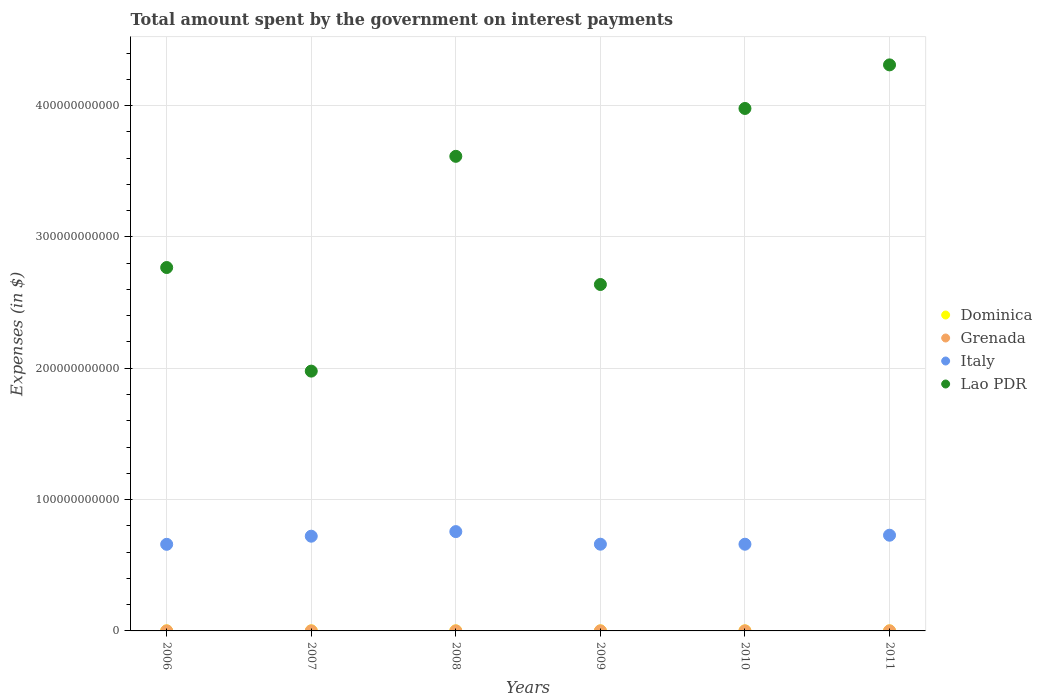Is the number of dotlines equal to the number of legend labels?
Give a very brief answer. Yes. What is the amount spent on interest payments by the government in Lao PDR in 2007?
Give a very brief answer. 1.98e+11. Across all years, what is the maximum amount spent on interest payments by the government in Lao PDR?
Offer a terse response. 4.31e+11. Across all years, what is the minimum amount spent on interest payments by the government in Dominica?
Your answer should be very brief. 1.41e+07. What is the total amount spent on interest payments by the government in Italy in the graph?
Give a very brief answer. 4.19e+11. What is the difference between the amount spent on interest payments by the government in Lao PDR in 2006 and that in 2009?
Your answer should be compact. 1.29e+1. What is the difference between the amount spent on interest payments by the government in Lao PDR in 2007 and the amount spent on interest payments by the government in Italy in 2008?
Ensure brevity in your answer.  1.22e+11. What is the average amount spent on interest payments by the government in Italy per year?
Provide a short and direct response. 6.98e+1. In the year 2010, what is the difference between the amount spent on interest payments by the government in Grenada and amount spent on interest payments by the government in Lao PDR?
Offer a terse response. -3.98e+11. In how many years, is the amount spent on interest payments by the government in Lao PDR greater than 220000000000 $?
Provide a succinct answer. 5. What is the ratio of the amount spent on interest payments by the government in Dominica in 2006 to that in 2008?
Your answer should be compact. 1.41. Is the amount spent on interest payments by the government in Grenada in 2006 less than that in 2010?
Provide a short and direct response. Yes. Is the difference between the amount spent on interest payments by the government in Grenada in 2008 and 2009 greater than the difference between the amount spent on interest payments by the government in Lao PDR in 2008 and 2009?
Your answer should be very brief. No. What is the difference between the highest and the second highest amount spent on interest payments by the government in Grenada?
Offer a very short reply. 6.30e+06. What is the difference between the highest and the lowest amount spent on interest payments by the government in Dominica?
Keep it short and to the point. 2.05e+07. Is it the case that in every year, the sum of the amount spent on interest payments by the government in Grenada and amount spent on interest payments by the government in Dominica  is greater than the sum of amount spent on interest payments by the government in Italy and amount spent on interest payments by the government in Lao PDR?
Provide a short and direct response. No. Does the amount spent on interest payments by the government in Italy monotonically increase over the years?
Make the answer very short. No. What is the difference between two consecutive major ticks on the Y-axis?
Offer a very short reply. 1.00e+11. Are the values on the major ticks of Y-axis written in scientific E-notation?
Ensure brevity in your answer.  No. Does the graph contain any zero values?
Offer a very short reply. No. Does the graph contain grids?
Give a very brief answer. Yes. Where does the legend appear in the graph?
Make the answer very short. Center right. What is the title of the graph?
Provide a succinct answer. Total amount spent by the government on interest payments. What is the label or title of the X-axis?
Ensure brevity in your answer.  Years. What is the label or title of the Y-axis?
Your answer should be compact. Expenses (in $). What is the Expenses (in $) of Dominica in 2006?
Make the answer very short. 3.46e+07. What is the Expenses (in $) of Grenada in 2006?
Your answer should be very brief. 2.90e+07. What is the Expenses (in $) of Italy in 2006?
Provide a succinct answer. 6.59e+1. What is the Expenses (in $) of Lao PDR in 2006?
Your response must be concise. 2.77e+11. What is the Expenses (in $) of Dominica in 2007?
Your response must be concise. 2.82e+07. What is the Expenses (in $) of Grenada in 2007?
Your answer should be very brief. 3.30e+07. What is the Expenses (in $) in Italy in 2007?
Offer a very short reply. 7.21e+1. What is the Expenses (in $) in Lao PDR in 2007?
Give a very brief answer. 1.98e+11. What is the Expenses (in $) of Dominica in 2008?
Your answer should be very brief. 2.45e+07. What is the Expenses (in $) in Grenada in 2008?
Provide a succinct answer. 3.49e+07. What is the Expenses (in $) of Italy in 2008?
Give a very brief answer. 7.56e+1. What is the Expenses (in $) in Lao PDR in 2008?
Your response must be concise. 3.61e+11. What is the Expenses (in $) of Dominica in 2009?
Your answer should be compact. 1.41e+07. What is the Expenses (in $) in Grenada in 2009?
Provide a succinct answer. 4.53e+07. What is the Expenses (in $) in Italy in 2009?
Ensure brevity in your answer.  6.60e+1. What is the Expenses (in $) in Lao PDR in 2009?
Provide a succinct answer. 2.64e+11. What is the Expenses (in $) in Dominica in 2010?
Ensure brevity in your answer.  2.10e+07. What is the Expenses (in $) of Grenada in 2010?
Give a very brief answer. 4.30e+07. What is the Expenses (in $) of Italy in 2010?
Your answer should be compact. 6.60e+1. What is the Expenses (in $) in Lao PDR in 2010?
Your answer should be compact. 3.98e+11. What is the Expenses (in $) of Dominica in 2011?
Ensure brevity in your answer.  2.46e+07. What is the Expenses (in $) of Grenada in 2011?
Provide a short and direct response. 5.16e+07. What is the Expenses (in $) in Italy in 2011?
Give a very brief answer. 7.29e+1. What is the Expenses (in $) in Lao PDR in 2011?
Make the answer very short. 4.31e+11. Across all years, what is the maximum Expenses (in $) in Dominica?
Offer a terse response. 3.46e+07. Across all years, what is the maximum Expenses (in $) of Grenada?
Your response must be concise. 5.16e+07. Across all years, what is the maximum Expenses (in $) of Italy?
Provide a succinct answer. 7.56e+1. Across all years, what is the maximum Expenses (in $) in Lao PDR?
Your answer should be very brief. 4.31e+11. Across all years, what is the minimum Expenses (in $) in Dominica?
Keep it short and to the point. 1.41e+07. Across all years, what is the minimum Expenses (in $) of Grenada?
Ensure brevity in your answer.  2.90e+07. Across all years, what is the minimum Expenses (in $) of Italy?
Your answer should be very brief. 6.59e+1. Across all years, what is the minimum Expenses (in $) of Lao PDR?
Your response must be concise. 1.98e+11. What is the total Expenses (in $) of Dominica in the graph?
Keep it short and to the point. 1.47e+08. What is the total Expenses (in $) in Grenada in the graph?
Your answer should be very brief. 2.37e+08. What is the total Expenses (in $) of Italy in the graph?
Provide a succinct answer. 4.19e+11. What is the total Expenses (in $) of Lao PDR in the graph?
Make the answer very short. 1.93e+12. What is the difference between the Expenses (in $) of Dominica in 2006 and that in 2007?
Give a very brief answer. 6.40e+06. What is the difference between the Expenses (in $) of Italy in 2006 and that in 2007?
Keep it short and to the point. -6.18e+09. What is the difference between the Expenses (in $) in Lao PDR in 2006 and that in 2007?
Your answer should be very brief. 7.89e+1. What is the difference between the Expenses (in $) in Dominica in 2006 and that in 2008?
Provide a succinct answer. 1.01e+07. What is the difference between the Expenses (in $) of Grenada in 2006 and that in 2008?
Keep it short and to the point. -5.90e+06. What is the difference between the Expenses (in $) in Italy in 2006 and that in 2008?
Your answer should be compact. -9.68e+09. What is the difference between the Expenses (in $) of Lao PDR in 2006 and that in 2008?
Give a very brief answer. -8.47e+1. What is the difference between the Expenses (in $) in Dominica in 2006 and that in 2009?
Offer a terse response. 2.05e+07. What is the difference between the Expenses (in $) of Grenada in 2006 and that in 2009?
Your answer should be compact. -1.63e+07. What is the difference between the Expenses (in $) in Italy in 2006 and that in 2009?
Your answer should be very brief. -8.80e+07. What is the difference between the Expenses (in $) in Lao PDR in 2006 and that in 2009?
Offer a terse response. 1.29e+1. What is the difference between the Expenses (in $) of Dominica in 2006 and that in 2010?
Provide a succinct answer. 1.36e+07. What is the difference between the Expenses (in $) of Grenada in 2006 and that in 2010?
Offer a very short reply. -1.40e+07. What is the difference between the Expenses (in $) in Italy in 2006 and that in 2010?
Give a very brief answer. -7.20e+07. What is the difference between the Expenses (in $) of Lao PDR in 2006 and that in 2010?
Offer a terse response. -1.21e+11. What is the difference between the Expenses (in $) of Dominica in 2006 and that in 2011?
Offer a terse response. 1.00e+07. What is the difference between the Expenses (in $) in Grenada in 2006 and that in 2011?
Your answer should be compact. -2.26e+07. What is the difference between the Expenses (in $) in Italy in 2006 and that in 2011?
Offer a very short reply. -6.93e+09. What is the difference between the Expenses (in $) of Lao PDR in 2006 and that in 2011?
Provide a short and direct response. -1.54e+11. What is the difference between the Expenses (in $) in Dominica in 2007 and that in 2008?
Your answer should be compact. 3.70e+06. What is the difference between the Expenses (in $) in Grenada in 2007 and that in 2008?
Your response must be concise. -1.90e+06. What is the difference between the Expenses (in $) of Italy in 2007 and that in 2008?
Your answer should be very brief. -3.50e+09. What is the difference between the Expenses (in $) in Lao PDR in 2007 and that in 2008?
Your response must be concise. -1.64e+11. What is the difference between the Expenses (in $) of Dominica in 2007 and that in 2009?
Your answer should be very brief. 1.41e+07. What is the difference between the Expenses (in $) of Grenada in 2007 and that in 2009?
Your answer should be compact. -1.23e+07. What is the difference between the Expenses (in $) of Italy in 2007 and that in 2009?
Ensure brevity in your answer.  6.09e+09. What is the difference between the Expenses (in $) in Lao PDR in 2007 and that in 2009?
Keep it short and to the point. -6.60e+1. What is the difference between the Expenses (in $) in Dominica in 2007 and that in 2010?
Offer a very short reply. 7.20e+06. What is the difference between the Expenses (in $) in Grenada in 2007 and that in 2010?
Provide a short and direct response. -1.00e+07. What is the difference between the Expenses (in $) of Italy in 2007 and that in 2010?
Provide a succinct answer. 6.11e+09. What is the difference between the Expenses (in $) of Lao PDR in 2007 and that in 2010?
Your answer should be very brief. -2.00e+11. What is the difference between the Expenses (in $) of Dominica in 2007 and that in 2011?
Provide a short and direct response. 3.60e+06. What is the difference between the Expenses (in $) in Grenada in 2007 and that in 2011?
Ensure brevity in your answer.  -1.86e+07. What is the difference between the Expenses (in $) of Italy in 2007 and that in 2011?
Make the answer very short. -7.51e+08. What is the difference between the Expenses (in $) of Lao PDR in 2007 and that in 2011?
Give a very brief answer. -2.33e+11. What is the difference between the Expenses (in $) in Dominica in 2008 and that in 2009?
Offer a terse response. 1.04e+07. What is the difference between the Expenses (in $) of Grenada in 2008 and that in 2009?
Your answer should be compact. -1.04e+07. What is the difference between the Expenses (in $) in Italy in 2008 and that in 2009?
Your response must be concise. 9.59e+09. What is the difference between the Expenses (in $) of Lao PDR in 2008 and that in 2009?
Ensure brevity in your answer.  9.76e+1. What is the difference between the Expenses (in $) of Dominica in 2008 and that in 2010?
Provide a short and direct response. 3.50e+06. What is the difference between the Expenses (in $) in Grenada in 2008 and that in 2010?
Your answer should be compact. -8.10e+06. What is the difference between the Expenses (in $) in Italy in 2008 and that in 2010?
Ensure brevity in your answer.  9.61e+09. What is the difference between the Expenses (in $) of Lao PDR in 2008 and that in 2010?
Your answer should be compact. -3.64e+1. What is the difference between the Expenses (in $) of Dominica in 2008 and that in 2011?
Offer a very short reply. -1.00e+05. What is the difference between the Expenses (in $) in Grenada in 2008 and that in 2011?
Give a very brief answer. -1.67e+07. What is the difference between the Expenses (in $) of Italy in 2008 and that in 2011?
Give a very brief answer. 2.75e+09. What is the difference between the Expenses (in $) of Lao PDR in 2008 and that in 2011?
Provide a short and direct response. -6.96e+1. What is the difference between the Expenses (in $) in Dominica in 2009 and that in 2010?
Offer a terse response. -6.90e+06. What is the difference between the Expenses (in $) in Grenada in 2009 and that in 2010?
Your response must be concise. 2.30e+06. What is the difference between the Expenses (in $) of Italy in 2009 and that in 2010?
Keep it short and to the point. 1.60e+07. What is the difference between the Expenses (in $) of Lao PDR in 2009 and that in 2010?
Keep it short and to the point. -1.34e+11. What is the difference between the Expenses (in $) of Dominica in 2009 and that in 2011?
Offer a terse response. -1.05e+07. What is the difference between the Expenses (in $) of Grenada in 2009 and that in 2011?
Provide a short and direct response. -6.30e+06. What is the difference between the Expenses (in $) of Italy in 2009 and that in 2011?
Provide a succinct answer. -6.84e+09. What is the difference between the Expenses (in $) of Lao PDR in 2009 and that in 2011?
Your answer should be compact. -1.67e+11. What is the difference between the Expenses (in $) of Dominica in 2010 and that in 2011?
Ensure brevity in your answer.  -3.60e+06. What is the difference between the Expenses (in $) in Grenada in 2010 and that in 2011?
Your response must be concise. -8.60e+06. What is the difference between the Expenses (in $) in Italy in 2010 and that in 2011?
Give a very brief answer. -6.86e+09. What is the difference between the Expenses (in $) in Lao PDR in 2010 and that in 2011?
Make the answer very short. -3.32e+1. What is the difference between the Expenses (in $) of Dominica in 2006 and the Expenses (in $) of Grenada in 2007?
Your response must be concise. 1.60e+06. What is the difference between the Expenses (in $) in Dominica in 2006 and the Expenses (in $) in Italy in 2007?
Keep it short and to the point. -7.21e+1. What is the difference between the Expenses (in $) in Dominica in 2006 and the Expenses (in $) in Lao PDR in 2007?
Ensure brevity in your answer.  -1.98e+11. What is the difference between the Expenses (in $) in Grenada in 2006 and the Expenses (in $) in Italy in 2007?
Provide a succinct answer. -7.21e+1. What is the difference between the Expenses (in $) in Grenada in 2006 and the Expenses (in $) in Lao PDR in 2007?
Ensure brevity in your answer.  -1.98e+11. What is the difference between the Expenses (in $) in Italy in 2006 and the Expenses (in $) in Lao PDR in 2007?
Give a very brief answer. -1.32e+11. What is the difference between the Expenses (in $) in Dominica in 2006 and the Expenses (in $) in Grenada in 2008?
Make the answer very short. -3.00e+05. What is the difference between the Expenses (in $) in Dominica in 2006 and the Expenses (in $) in Italy in 2008?
Ensure brevity in your answer.  -7.56e+1. What is the difference between the Expenses (in $) in Dominica in 2006 and the Expenses (in $) in Lao PDR in 2008?
Keep it short and to the point. -3.61e+11. What is the difference between the Expenses (in $) in Grenada in 2006 and the Expenses (in $) in Italy in 2008?
Keep it short and to the point. -7.56e+1. What is the difference between the Expenses (in $) in Grenada in 2006 and the Expenses (in $) in Lao PDR in 2008?
Your response must be concise. -3.61e+11. What is the difference between the Expenses (in $) of Italy in 2006 and the Expenses (in $) of Lao PDR in 2008?
Keep it short and to the point. -2.95e+11. What is the difference between the Expenses (in $) in Dominica in 2006 and the Expenses (in $) in Grenada in 2009?
Ensure brevity in your answer.  -1.07e+07. What is the difference between the Expenses (in $) in Dominica in 2006 and the Expenses (in $) in Italy in 2009?
Your answer should be very brief. -6.60e+1. What is the difference between the Expenses (in $) of Dominica in 2006 and the Expenses (in $) of Lao PDR in 2009?
Offer a terse response. -2.64e+11. What is the difference between the Expenses (in $) in Grenada in 2006 and the Expenses (in $) in Italy in 2009?
Ensure brevity in your answer.  -6.60e+1. What is the difference between the Expenses (in $) of Grenada in 2006 and the Expenses (in $) of Lao PDR in 2009?
Provide a succinct answer. -2.64e+11. What is the difference between the Expenses (in $) of Italy in 2006 and the Expenses (in $) of Lao PDR in 2009?
Offer a very short reply. -1.98e+11. What is the difference between the Expenses (in $) in Dominica in 2006 and the Expenses (in $) in Grenada in 2010?
Give a very brief answer. -8.40e+06. What is the difference between the Expenses (in $) in Dominica in 2006 and the Expenses (in $) in Italy in 2010?
Your answer should be compact. -6.60e+1. What is the difference between the Expenses (in $) in Dominica in 2006 and the Expenses (in $) in Lao PDR in 2010?
Make the answer very short. -3.98e+11. What is the difference between the Expenses (in $) of Grenada in 2006 and the Expenses (in $) of Italy in 2010?
Your answer should be compact. -6.60e+1. What is the difference between the Expenses (in $) of Grenada in 2006 and the Expenses (in $) of Lao PDR in 2010?
Offer a terse response. -3.98e+11. What is the difference between the Expenses (in $) in Italy in 2006 and the Expenses (in $) in Lao PDR in 2010?
Keep it short and to the point. -3.32e+11. What is the difference between the Expenses (in $) of Dominica in 2006 and the Expenses (in $) of Grenada in 2011?
Keep it short and to the point. -1.70e+07. What is the difference between the Expenses (in $) of Dominica in 2006 and the Expenses (in $) of Italy in 2011?
Make the answer very short. -7.28e+1. What is the difference between the Expenses (in $) of Dominica in 2006 and the Expenses (in $) of Lao PDR in 2011?
Ensure brevity in your answer.  -4.31e+11. What is the difference between the Expenses (in $) of Grenada in 2006 and the Expenses (in $) of Italy in 2011?
Give a very brief answer. -7.28e+1. What is the difference between the Expenses (in $) of Grenada in 2006 and the Expenses (in $) of Lao PDR in 2011?
Offer a terse response. -4.31e+11. What is the difference between the Expenses (in $) in Italy in 2006 and the Expenses (in $) in Lao PDR in 2011?
Provide a short and direct response. -3.65e+11. What is the difference between the Expenses (in $) of Dominica in 2007 and the Expenses (in $) of Grenada in 2008?
Keep it short and to the point. -6.70e+06. What is the difference between the Expenses (in $) of Dominica in 2007 and the Expenses (in $) of Italy in 2008?
Ensure brevity in your answer.  -7.56e+1. What is the difference between the Expenses (in $) of Dominica in 2007 and the Expenses (in $) of Lao PDR in 2008?
Your response must be concise. -3.61e+11. What is the difference between the Expenses (in $) of Grenada in 2007 and the Expenses (in $) of Italy in 2008?
Offer a terse response. -7.56e+1. What is the difference between the Expenses (in $) of Grenada in 2007 and the Expenses (in $) of Lao PDR in 2008?
Offer a terse response. -3.61e+11. What is the difference between the Expenses (in $) of Italy in 2007 and the Expenses (in $) of Lao PDR in 2008?
Keep it short and to the point. -2.89e+11. What is the difference between the Expenses (in $) of Dominica in 2007 and the Expenses (in $) of Grenada in 2009?
Your answer should be compact. -1.71e+07. What is the difference between the Expenses (in $) in Dominica in 2007 and the Expenses (in $) in Italy in 2009?
Your response must be concise. -6.60e+1. What is the difference between the Expenses (in $) of Dominica in 2007 and the Expenses (in $) of Lao PDR in 2009?
Your response must be concise. -2.64e+11. What is the difference between the Expenses (in $) of Grenada in 2007 and the Expenses (in $) of Italy in 2009?
Provide a succinct answer. -6.60e+1. What is the difference between the Expenses (in $) in Grenada in 2007 and the Expenses (in $) in Lao PDR in 2009?
Make the answer very short. -2.64e+11. What is the difference between the Expenses (in $) in Italy in 2007 and the Expenses (in $) in Lao PDR in 2009?
Provide a succinct answer. -1.92e+11. What is the difference between the Expenses (in $) of Dominica in 2007 and the Expenses (in $) of Grenada in 2010?
Provide a short and direct response. -1.48e+07. What is the difference between the Expenses (in $) of Dominica in 2007 and the Expenses (in $) of Italy in 2010?
Keep it short and to the point. -6.60e+1. What is the difference between the Expenses (in $) of Dominica in 2007 and the Expenses (in $) of Lao PDR in 2010?
Provide a short and direct response. -3.98e+11. What is the difference between the Expenses (in $) of Grenada in 2007 and the Expenses (in $) of Italy in 2010?
Offer a terse response. -6.60e+1. What is the difference between the Expenses (in $) of Grenada in 2007 and the Expenses (in $) of Lao PDR in 2010?
Make the answer very short. -3.98e+11. What is the difference between the Expenses (in $) of Italy in 2007 and the Expenses (in $) of Lao PDR in 2010?
Your answer should be very brief. -3.26e+11. What is the difference between the Expenses (in $) of Dominica in 2007 and the Expenses (in $) of Grenada in 2011?
Offer a terse response. -2.34e+07. What is the difference between the Expenses (in $) of Dominica in 2007 and the Expenses (in $) of Italy in 2011?
Keep it short and to the point. -7.28e+1. What is the difference between the Expenses (in $) of Dominica in 2007 and the Expenses (in $) of Lao PDR in 2011?
Provide a succinct answer. -4.31e+11. What is the difference between the Expenses (in $) of Grenada in 2007 and the Expenses (in $) of Italy in 2011?
Your answer should be compact. -7.28e+1. What is the difference between the Expenses (in $) of Grenada in 2007 and the Expenses (in $) of Lao PDR in 2011?
Offer a terse response. -4.31e+11. What is the difference between the Expenses (in $) of Italy in 2007 and the Expenses (in $) of Lao PDR in 2011?
Give a very brief answer. -3.59e+11. What is the difference between the Expenses (in $) in Dominica in 2008 and the Expenses (in $) in Grenada in 2009?
Provide a short and direct response. -2.08e+07. What is the difference between the Expenses (in $) of Dominica in 2008 and the Expenses (in $) of Italy in 2009?
Offer a terse response. -6.60e+1. What is the difference between the Expenses (in $) in Dominica in 2008 and the Expenses (in $) in Lao PDR in 2009?
Provide a succinct answer. -2.64e+11. What is the difference between the Expenses (in $) in Grenada in 2008 and the Expenses (in $) in Italy in 2009?
Provide a succinct answer. -6.60e+1. What is the difference between the Expenses (in $) in Grenada in 2008 and the Expenses (in $) in Lao PDR in 2009?
Give a very brief answer. -2.64e+11. What is the difference between the Expenses (in $) in Italy in 2008 and the Expenses (in $) in Lao PDR in 2009?
Give a very brief answer. -1.88e+11. What is the difference between the Expenses (in $) in Dominica in 2008 and the Expenses (in $) in Grenada in 2010?
Make the answer very short. -1.85e+07. What is the difference between the Expenses (in $) of Dominica in 2008 and the Expenses (in $) of Italy in 2010?
Give a very brief answer. -6.60e+1. What is the difference between the Expenses (in $) of Dominica in 2008 and the Expenses (in $) of Lao PDR in 2010?
Your answer should be very brief. -3.98e+11. What is the difference between the Expenses (in $) of Grenada in 2008 and the Expenses (in $) of Italy in 2010?
Offer a terse response. -6.60e+1. What is the difference between the Expenses (in $) in Grenada in 2008 and the Expenses (in $) in Lao PDR in 2010?
Give a very brief answer. -3.98e+11. What is the difference between the Expenses (in $) in Italy in 2008 and the Expenses (in $) in Lao PDR in 2010?
Provide a short and direct response. -3.22e+11. What is the difference between the Expenses (in $) of Dominica in 2008 and the Expenses (in $) of Grenada in 2011?
Offer a very short reply. -2.71e+07. What is the difference between the Expenses (in $) of Dominica in 2008 and the Expenses (in $) of Italy in 2011?
Give a very brief answer. -7.28e+1. What is the difference between the Expenses (in $) in Dominica in 2008 and the Expenses (in $) in Lao PDR in 2011?
Your response must be concise. -4.31e+11. What is the difference between the Expenses (in $) in Grenada in 2008 and the Expenses (in $) in Italy in 2011?
Your response must be concise. -7.28e+1. What is the difference between the Expenses (in $) in Grenada in 2008 and the Expenses (in $) in Lao PDR in 2011?
Ensure brevity in your answer.  -4.31e+11. What is the difference between the Expenses (in $) in Italy in 2008 and the Expenses (in $) in Lao PDR in 2011?
Offer a terse response. -3.55e+11. What is the difference between the Expenses (in $) of Dominica in 2009 and the Expenses (in $) of Grenada in 2010?
Your answer should be very brief. -2.89e+07. What is the difference between the Expenses (in $) in Dominica in 2009 and the Expenses (in $) in Italy in 2010?
Offer a terse response. -6.60e+1. What is the difference between the Expenses (in $) of Dominica in 2009 and the Expenses (in $) of Lao PDR in 2010?
Offer a very short reply. -3.98e+11. What is the difference between the Expenses (in $) in Grenada in 2009 and the Expenses (in $) in Italy in 2010?
Make the answer very short. -6.60e+1. What is the difference between the Expenses (in $) in Grenada in 2009 and the Expenses (in $) in Lao PDR in 2010?
Provide a succinct answer. -3.98e+11. What is the difference between the Expenses (in $) of Italy in 2009 and the Expenses (in $) of Lao PDR in 2010?
Offer a very short reply. -3.32e+11. What is the difference between the Expenses (in $) of Dominica in 2009 and the Expenses (in $) of Grenada in 2011?
Your answer should be very brief. -3.75e+07. What is the difference between the Expenses (in $) in Dominica in 2009 and the Expenses (in $) in Italy in 2011?
Offer a very short reply. -7.29e+1. What is the difference between the Expenses (in $) in Dominica in 2009 and the Expenses (in $) in Lao PDR in 2011?
Give a very brief answer. -4.31e+11. What is the difference between the Expenses (in $) of Grenada in 2009 and the Expenses (in $) of Italy in 2011?
Your response must be concise. -7.28e+1. What is the difference between the Expenses (in $) of Grenada in 2009 and the Expenses (in $) of Lao PDR in 2011?
Make the answer very short. -4.31e+11. What is the difference between the Expenses (in $) of Italy in 2009 and the Expenses (in $) of Lao PDR in 2011?
Your response must be concise. -3.65e+11. What is the difference between the Expenses (in $) of Dominica in 2010 and the Expenses (in $) of Grenada in 2011?
Offer a terse response. -3.06e+07. What is the difference between the Expenses (in $) of Dominica in 2010 and the Expenses (in $) of Italy in 2011?
Offer a very short reply. -7.29e+1. What is the difference between the Expenses (in $) in Dominica in 2010 and the Expenses (in $) in Lao PDR in 2011?
Give a very brief answer. -4.31e+11. What is the difference between the Expenses (in $) of Grenada in 2010 and the Expenses (in $) of Italy in 2011?
Keep it short and to the point. -7.28e+1. What is the difference between the Expenses (in $) in Grenada in 2010 and the Expenses (in $) in Lao PDR in 2011?
Give a very brief answer. -4.31e+11. What is the difference between the Expenses (in $) of Italy in 2010 and the Expenses (in $) of Lao PDR in 2011?
Provide a succinct answer. -3.65e+11. What is the average Expenses (in $) in Dominica per year?
Provide a short and direct response. 2.45e+07. What is the average Expenses (in $) in Grenada per year?
Give a very brief answer. 3.95e+07. What is the average Expenses (in $) in Italy per year?
Offer a very short reply. 6.98e+1. What is the average Expenses (in $) of Lao PDR per year?
Provide a short and direct response. 3.21e+11. In the year 2006, what is the difference between the Expenses (in $) in Dominica and Expenses (in $) in Grenada?
Keep it short and to the point. 5.60e+06. In the year 2006, what is the difference between the Expenses (in $) of Dominica and Expenses (in $) of Italy?
Make the answer very short. -6.59e+1. In the year 2006, what is the difference between the Expenses (in $) of Dominica and Expenses (in $) of Lao PDR?
Ensure brevity in your answer.  -2.77e+11. In the year 2006, what is the difference between the Expenses (in $) of Grenada and Expenses (in $) of Italy?
Offer a very short reply. -6.59e+1. In the year 2006, what is the difference between the Expenses (in $) of Grenada and Expenses (in $) of Lao PDR?
Your response must be concise. -2.77e+11. In the year 2006, what is the difference between the Expenses (in $) in Italy and Expenses (in $) in Lao PDR?
Make the answer very short. -2.11e+11. In the year 2007, what is the difference between the Expenses (in $) in Dominica and Expenses (in $) in Grenada?
Ensure brevity in your answer.  -4.80e+06. In the year 2007, what is the difference between the Expenses (in $) in Dominica and Expenses (in $) in Italy?
Make the answer very short. -7.21e+1. In the year 2007, what is the difference between the Expenses (in $) in Dominica and Expenses (in $) in Lao PDR?
Ensure brevity in your answer.  -1.98e+11. In the year 2007, what is the difference between the Expenses (in $) in Grenada and Expenses (in $) in Italy?
Your response must be concise. -7.21e+1. In the year 2007, what is the difference between the Expenses (in $) of Grenada and Expenses (in $) of Lao PDR?
Provide a short and direct response. -1.98e+11. In the year 2007, what is the difference between the Expenses (in $) in Italy and Expenses (in $) in Lao PDR?
Your answer should be very brief. -1.26e+11. In the year 2008, what is the difference between the Expenses (in $) of Dominica and Expenses (in $) of Grenada?
Your answer should be compact. -1.04e+07. In the year 2008, what is the difference between the Expenses (in $) in Dominica and Expenses (in $) in Italy?
Offer a terse response. -7.56e+1. In the year 2008, what is the difference between the Expenses (in $) in Dominica and Expenses (in $) in Lao PDR?
Offer a very short reply. -3.61e+11. In the year 2008, what is the difference between the Expenses (in $) of Grenada and Expenses (in $) of Italy?
Give a very brief answer. -7.56e+1. In the year 2008, what is the difference between the Expenses (in $) in Grenada and Expenses (in $) in Lao PDR?
Offer a terse response. -3.61e+11. In the year 2008, what is the difference between the Expenses (in $) of Italy and Expenses (in $) of Lao PDR?
Make the answer very short. -2.86e+11. In the year 2009, what is the difference between the Expenses (in $) of Dominica and Expenses (in $) of Grenada?
Ensure brevity in your answer.  -3.12e+07. In the year 2009, what is the difference between the Expenses (in $) of Dominica and Expenses (in $) of Italy?
Provide a succinct answer. -6.60e+1. In the year 2009, what is the difference between the Expenses (in $) in Dominica and Expenses (in $) in Lao PDR?
Provide a succinct answer. -2.64e+11. In the year 2009, what is the difference between the Expenses (in $) in Grenada and Expenses (in $) in Italy?
Make the answer very short. -6.60e+1. In the year 2009, what is the difference between the Expenses (in $) of Grenada and Expenses (in $) of Lao PDR?
Keep it short and to the point. -2.64e+11. In the year 2009, what is the difference between the Expenses (in $) in Italy and Expenses (in $) in Lao PDR?
Your response must be concise. -1.98e+11. In the year 2010, what is the difference between the Expenses (in $) in Dominica and Expenses (in $) in Grenada?
Your answer should be very brief. -2.20e+07. In the year 2010, what is the difference between the Expenses (in $) of Dominica and Expenses (in $) of Italy?
Offer a terse response. -6.60e+1. In the year 2010, what is the difference between the Expenses (in $) in Dominica and Expenses (in $) in Lao PDR?
Your response must be concise. -3.98e+11. In the year 2010, what is the difference between the Expenses (in $) in Grenada and Expenses (in $) in Italy?
Ensure brevity in your answer.  -6.60e+1. In the year 2010, what is the difference between the Expenses (in $) in Grenada and Expenses (in $) in Lao PDR?
Ensure brevity in your answer.  -3.98e+11. In the year 2010, what is the difference between the Expenses (in $) of Italy and Expenses (in $) of Lao PDR?
Provide a short and direct response. -3.32e+11. In the year 2011, what is the difference between the Expenses (in $) in Dominica and Expenses (in $) in Grenada?
Provide a succinct answer. -2.70e+07. In the year 2011, what is the difference between the Expenses (in $) of Dominica and Expenses (in $) of Italy?
Offer a terse response. -7.28e+1. In the year 2011, what is the difference between the Expenses (in $) of Dominica and Expenses (in $) of Lao PDR?
Provide a short and direct response. -4.31e+11. In the year 2011, what is the difference between the Expenses (in $) of Grenada and Expenses (in $) of Italy?
Offer a very short reply. -7.28e+1. In the year 2011, what is the difference between the Expenses (in $) in Grenada and Expenses (in $) in Lao PDR?
Offer a very short reply. -4.31e+11. In the year 2011, what is the difference between the Expenses (in $) of Italy and Expenses (in $) of Lao PDR?
Ensure brevity in your answer.  -3.58e+11. What is the ratio of the Expenses (in $) in Dominica in 2006 to that in 2007?
Your answer should be very brief. 1.23. What is the ratio of the Expenses (in $) in Grenada in 2006 to that in 2007?
Your answer should be compact. 0.88. What is the ratio of the Expenses (in $) of Italy in 2006 to that in 2007?
Offer a terse response. 0.91. What is the ratio of the Expenses (in $) of Lao PDR in 2006 to that in 2007?
Ensure brevity in your answer.  1.4. What is the ratio of the Expenses (in $) of Dominica in 2006 to that in 2008?
Your response must be concise. 1.41. What is the ratio of the Expenses (in $) in Grenada in 2006 to that in 2008?
Make the answer very short. 0.83. What is the ratio of the Expenses (in $) of Italy in 2006 to that in 2008?
Your answer should be very brief. 0.87. What is the ratio of the Expenses (in $) in Lao PDR in 2006 to that in 2008?
Your response must be concise. 0.77. What is the ratio of the Expenses (in $) of Dominica in 2006 to that in 2009?
Provide a short and direct response. 2.45. What is the ratio of the Expenses (in $) in Grenada in 2006 to that in 2009?
Provide a short and direct response. 0.64. What is the ratio of the Expenses (in $) of Italy in 2006 to that in 2009?
Offer a very short reply. 1. What is the ratio of the Expenses (in $) in Lao PDR in 2006 to that in 2009?
Ensure brevity in your answer.  1.05. What is the ratio of the Expenses (in $) in Dominica in 2006 to that in 2010?
Make the answer very short. 1.65. What is the ratio of the Expenses (in $) in Grenada in 2006 to that in 2010?
Offer a terse response. 0.67. What is the ratio of the Expenses (in $) in Lao PDR in 2006 to that in 2010?
Provide a succinct answer. 0.7. What is the ratio of the Expenses (in $) in Dominica in 2006 to that in 2011?
Make the answer very short. 1.41. What is the ratio of the Expenses (in $) of Grenada in 2006 to that in 2011?
Keep it short and to the point. 0.56. What is the ratio of the Expenses (in $) of Italy in 2006 to that in 2011?
Keep it short and to the point. 0.9. What is the ratio of the Expenses (in $) of Lao PDR in 2006 to that in 2011?
Make the answer very short. 0.64. What is the ratio of the Expenses (in $) in Dominica in 2007 to that in 2008?
Offer a terse response. 1.15. What is the ratio of the Expenses (in $) in Grenada in 2007 to that in 2008?
Make the answer very short. 0.95. What is the ratio of the Expenses (in $) in Italy in 2007 to that in 2008?
Your answer should be very brief. 0.95. What is the ratio of the Expenses (in $) of Lao PDR in 2007 to that in 2008?
Your response must be concise. 0.55. What is the ratio of the Expenses (in $) in Dominica in 2007 to that in 2009?
Your answer should be very brief. 2. What is the ratio of the Expenses (in $) of Grenada in 2007 to that in 2009?
Offer a very short reply. 0.73. What is the ratio of the Expenses (in $) in Italy in 2007 to that in 2009?
Offer a terse response. 1.09. What is the ratio of the Expenses (in $) in Lao PDR in 2007 to that in 2009?
Your answer should be compact. 0.75. What is the ratio of the Expenses (in $) in Dominica in 2007 to that in 2010?
Offer a terse response. 1.34. What is the ratio of the Expenses (in $) in Grenada in 2007 to that in 2010?
Ensure brevity in your answer.  0.77. What is the ratio of the Expenses (in $) in Italy in 2007 to that in 2010?
Your response must be concise. 1.09. What is the ratio of the Expenses (in $) of Lao PDR in 2007 to that in 2010?
Your answer should be compact. 0.5. What is the ratio of the Expenses (in $) in Dominica in 2007 to that in 2011?
Your answer should be very brief. 1.15. What is the ratio of the Expenses (in $) of Grenada in 2007 to that in 2011?
Provide a short and direct response. 0.64. What is the ratio of the Expenses (in $) in Italy in 2007 to that in 2011?
Your answer should be very brief. 0.99. What is the ratio of the Expenses (in $) of Lao PDR in 2007 to that in 2011?
Provide a succinct answer. 0.46. What is the ratio of the Expenses (in $) in Dominica in 2008 to that in 2009?
Provide a short and direct response. 1.74. What is the ratio of the Expenses (in $) of Grenada in 2008 to that in 2009?
Your answer should be very brief. 0.77. What is the ratio of the Expenses (in $) in Italy in 2008 to that in 2009?
Provide a succinct answer. 1.15. What is the ratio of the Expenses (in $) of Lao PDR in 2008 to that in 2009?
Offer a terse response. 1.37. What is the ratio of the Expenses (in $) in Dominica in 2008 to that in 2010?
Provide a succinct answer. 1.17. What is the ratio of the Expenses (in $) of Grenada in 2008 to that in 2010?
Give a very brief answer. 0.81. What is the ratio of the Expenses (in $) in Italy in 2008 to that in 2010?
Ensure brevity in your answer.  1.15. What is the ratio of the Expenses (in $) of Lao PDR in 2008 to that in 2010?
Keep it short and to the point. 0.91. What is the ratio of the Expenses (in $) in Dominica in 2008 to that in 2011?
Provide a succinct answer. 1. What is the ratio of the Expenses (in $) of Grenada in 2008 to that in 2011?
Make the answer very short. 0.68. What is the ratio of the Expenses (in $) of Italy in 2008 to that in 2011?
Keep it short and to the point. 1.04. What is the ratio of the Expenses (in $) of Lao PDR in 2008 to that in 2011?
Keep it short and to the point. 0.84. What is the ratio of the Expenses (in $) in Dominica in 2009 to that in 2010?
Your answer should be compact. 0.67. What is the ratio of the Expenses (in $) of Grenada in 2009 to that in 2010?
Provide a short and direct response. 1.05. What is the ratio of the Expenses (in $) of Lao PDR in 2009 to that in 2010?
Make the answer very short. 0.66. What is the ratio of the Expenses (in $) in Dominica in 2009 to that in 2011?
Offer a terse response. 0.57. What is the ratio of the Expenses (in $) of Grenada in 2009 to that in 2011?
Offer a terse response. 0.88. What is the ratio of the Expenses (in $) in Italy in 2009 to that in 2011?
Your response must be concise. 0.91. What is the ratio of the Expenses (in $) in Lao PDR in 2009 to that in 2011?
Your answer should be compact. 0.61. What is the ratio of the Expenses (in $) in Dominica in 2010 to that in 2011?
Your response must be concise. 0.85. What is the ratio of the Expenses (in $) of Grenada in 2010 to that in 2011?
Offer a terse response. 0.83. What is the ratio of the Expenses (in $) in Italy in 2010 to that in 2011?
Provide a short and direct response. 0.91. What is the ratio of the Expenses (in $) in Lao PDR in 2010 to that in 2011?
Offer a very short reply. 0.92. What is the difference between the highest and the second highest Expenses (in $) of Dominica?
Offer a terse response. 6.40e+06. What is the difference between the highest and the second highest Expenses (in $) of Grenada?
Your answer should be compact. 6.30e+06. What is the difference between the highest and the second highest Expenses (in $) in Italy?
Offer a very short reply. 2.75e+09. What is the difference between the highest and the second highest Expenses (in $) of Lao PDR?
Offer a very short reply. 3.32e+1. What is the difference between the highest and the lowest Expenses (in $) of Dominica?
Your response must be concise. 2.05e+07. What is the difference between the highest and the lowest Expenses (in $) in Grenada?
Make the answer very short. 2.26e+07. What is the difference between the highest and the lowest Expenses (in $) of Italy?
Provide a succinct answer. 9.68e+09. What is the difference between the highest and the lowest Expenses (in $) of Lao PDR?
Give a very brief answer. 2.33e+11. 